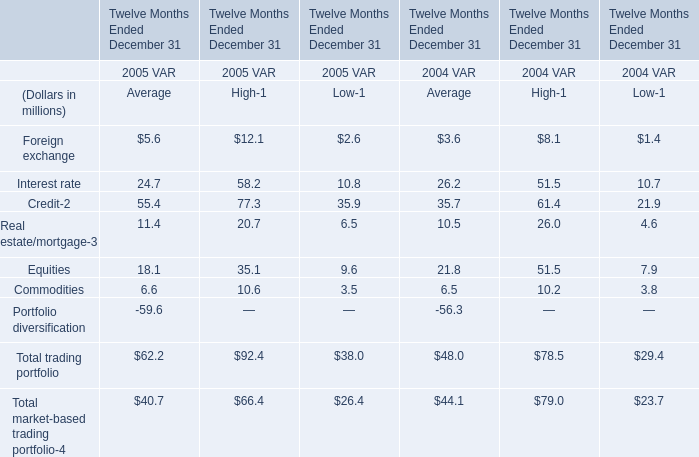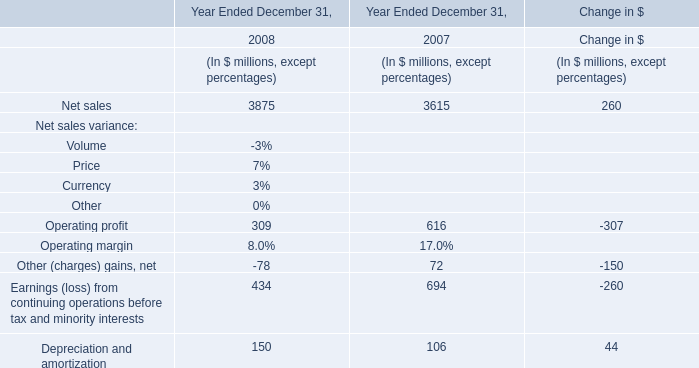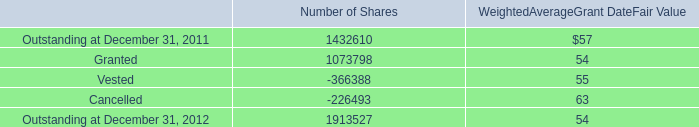what is the total value of cancelled shares , ( in millions ) ? 
Computations: ((226493 * 63) / 1000000)
Answer: 14.26906. 